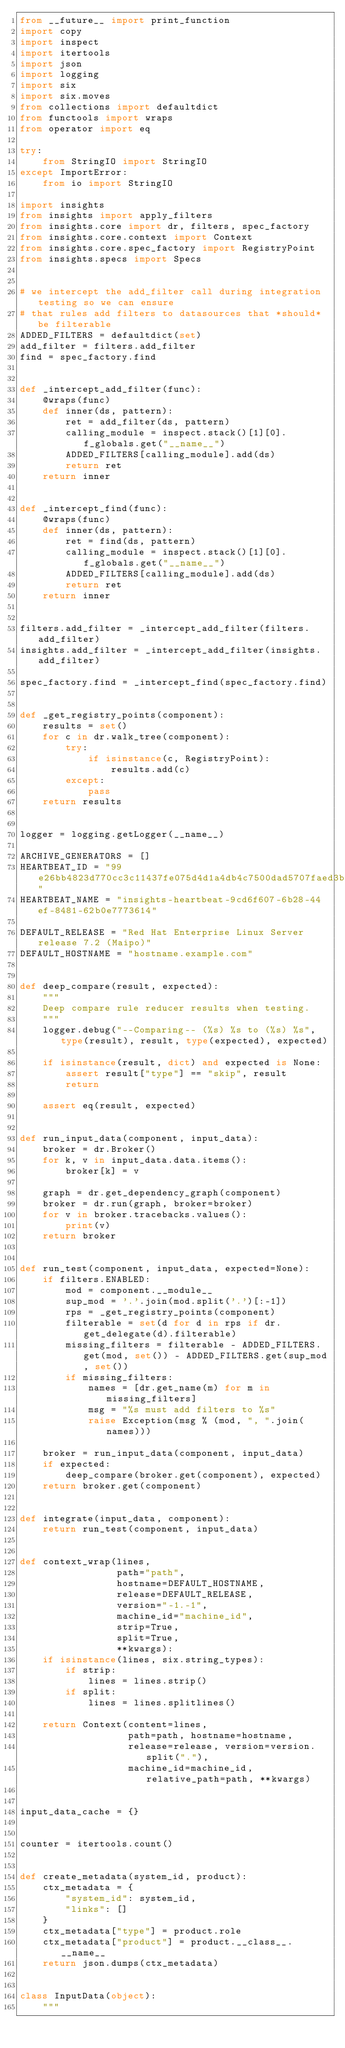<code> <loc_0><loc_0><loc_500><loc_500><_Python_>from __future__ import print_function
import copy
import inspect
import itertools
import json
import logging
import six
import six.moves
from collections import defaultdict
from functools import wraps
from operator import eq

try:
    from StringIO import StringIO
except ImportError:
    from io import StringIO

import insights
from insights import apply_filters
from insights.core import dr, filters, spec_factory
from insights.core.context import Context
from insights.core.spec_factory import RegistryPoint
from insights.specs import Specs


# we intercept the add_filter call during integration testing so we can ensure
# that rules add filters to datasources that *should* be filterable
ADDED_FILTERS = defaultdict(set)
add_filter = filters.add_filter
find = spec_factory.find


def _intercept_add_filter(func):
    @wraps(func)
    def inner(ds, pattern):
        ret = add_filter(ds, pattern)
        calling_module = inspect.stack()[1][0].f_globals.get("__name__")
        ADDED_FILTERS[calling_module].add(ds)
        return ret
    return inner


def _intercept_find(func):
    @wraps(func)
    def inner(ds, pattern):
        ret = find(ds, pattern)
        calling_module = inspect.stack()[1][0].f_globals.get("__name__")
        ADDED_FILTERS[calling_module].add(ds)
        return ret
    return inner


filters.add_filter = _intercept_add_filter(filters.add_filter)
insights.add_filter = _intercept_add_filter(insights.add_filter)

spec_factory.find = _intercept_find(spec_factory.find)


def _get_registry_points(component):
    results = set()
    for c in dr.walk_tree(component):
        try:
            if isinstance(c, RegistryPoint):
                results.add(c)
        except:
            pass
    return results


logger = logging.getLogger(__name__)

ARCHIVE_GENERATORS = []
HEARTBEAT_ID = "99e26bb4823d770cc3c11437fe075d4d1a4db4c7500dad5707faed3b"
HEARTBEAT_NAME = "insights-heartbeat-9cd6f607-6b28-44ef-8481-62b0e7773614"

DEFAULT_RELEASE = "Red Hat Enterprise Linux Server release 7.2 (Maipo)"
DEFAULT_HOSTNAME = "hostname.example.com"


def deep_compare(result, expected):
    """
    Deep compare rule reducer results when testing.
    """
    logger.debug("--Comparing-- (%s) %s to (%s) %s", type(result), result, type(expected), expected)

    if isinstance(result, dict) and expected is None:
        assert result["type"] == "skip", result
        return

    assert eq(result, expected)


def run_input_data(component, input_data):
    broker = dr.Broker()
    for k, v in input_data.data.items():
        broker[k] = v

    graph = dr.get_dependency_graph(component)
    broker = dr.run(graph, broker=broker)
    for v in broker.tracebacks.values():
        print(v)
    return broker


def run_test(component, input_data, expected=None):
    if filters.ENABLED:
        mod = component.__module__
        sup_mod = '.'.join(mod.split('.')[:-1])
        rps = _get_registry_points(component)
        filterable = set(d for d in rps if dr.get_delegate(d).filterable)
        missing_filters = filterable - ADDED_FILTERS.get(mod, set()) - ADDED_FILTERS.get(sup_mod, set())
        if missing_filters:
            names = [dr.get_name(m) for m in missing_filters]
            msg = "%s must add filters to %s"
            raise Exception(msg % (mod, ", ".join(names)))

    broker = run_input_data(component, input_data)
    if expected:
        deep_compare(broker.get(component), expected)
    return broker.get(component)


def integrate(input_data, component):
    return run_test(component, input_data)


def context_wrap(lines,
                 path="path",
                 hostname=DEFAULT_HOSTNAME,
                 release=DEFAULT_RELEASE,
                 version="-1.-1",
                 machine_id="machine_id",
                 strip=True,
                 split=True,
                 **kwargs):
    if isinstance(lines, six.string_types):
        if strip:
            lines = lines.strip()
        if split:
            lines = lines.splitlines()

    return Context(content=lines,
                   path=path, hostname=hostname,
                   release=release, version=version.split("."),
                   machine_id=machine_id, relative_path=path, **kwargs)


input_data_cache = {}


counter = itertools.count()


def create_metadata(system_id, product):
    ctx_metadata = {
        "system_id": system_id,
        "links": []
    }
    ctx_metadata["type"] = product.role
    ctx_metadata["product"] = product.__class__.__name__
    return json.dumps(ctx_metadata)


class InputData(object):
    """</code> 